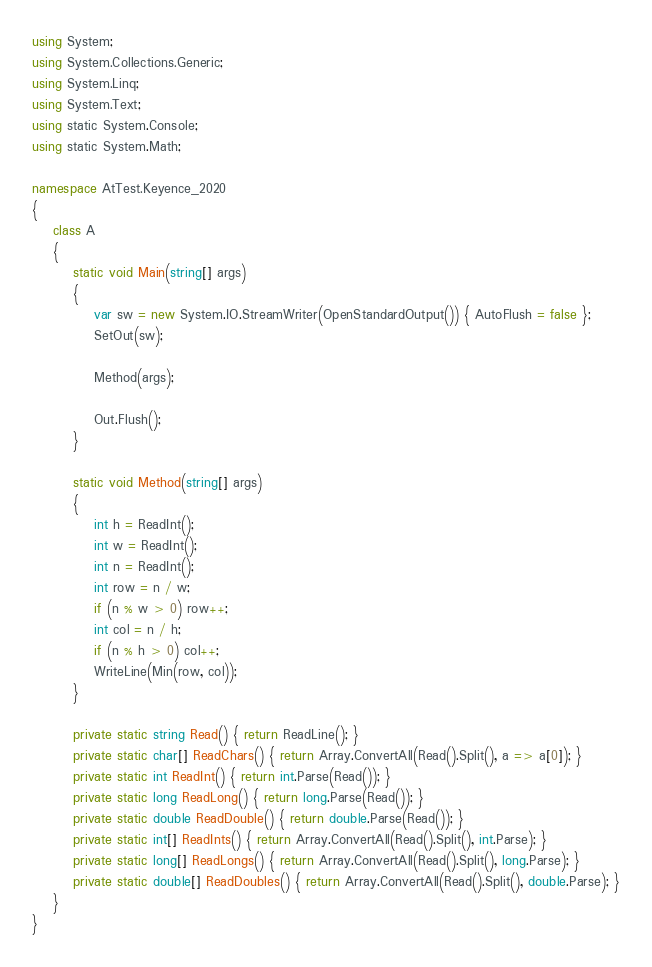<code> <loc_0><loc_0><loc_500><loc_500><_C#_>using System;
using System.Collections.Generic;
using System.Linq;
using System.Text;
using static System.Console;
using static System.Math;

namespace AtTest.Keyence_2020
{
    class A
    {
        static void Main(string[] args)
        {
            var sw = new System.IO.StreamWriter(OpenStandardOutput()) { AutoFlush = false };
            SetOut(sw);

            Method(args);

            Out.Flush();
        }

        static void Method(string[] args)
        {
            int h = ReadInt();
            int w = ReadInt();
            int n = ReadInt();
            int row = n / w;
            if (n % w > 0) row++;
            int col = n / h;
            if (n % h > 0) col++;
            WriteLine(Min(row, col));
        }

        private static string Read() { return ReadLine(); }
        private static char[] ReadChars() { return Array.ConvertAll(Read().Split(), a => a[0]); }
        private static int ReadInt() { return int.Parse(Read()); }
        private static long ReadLong() { return long.Parse(Read()); }
        private static double ReadDouble() { return double.Parse(Read()); }
        private static int[] ReadInts() { return Array.ConvertAll(Read().Split(), int.Parse); }
        private static long[] ReadLongs() { return Array.ConvertAll(Read().Split(), long.Parse); }
        private static double[] ReadDoubles() { return Array.ConvertAll(Read().Split(), double.Parse); }
    }
}
</code> 